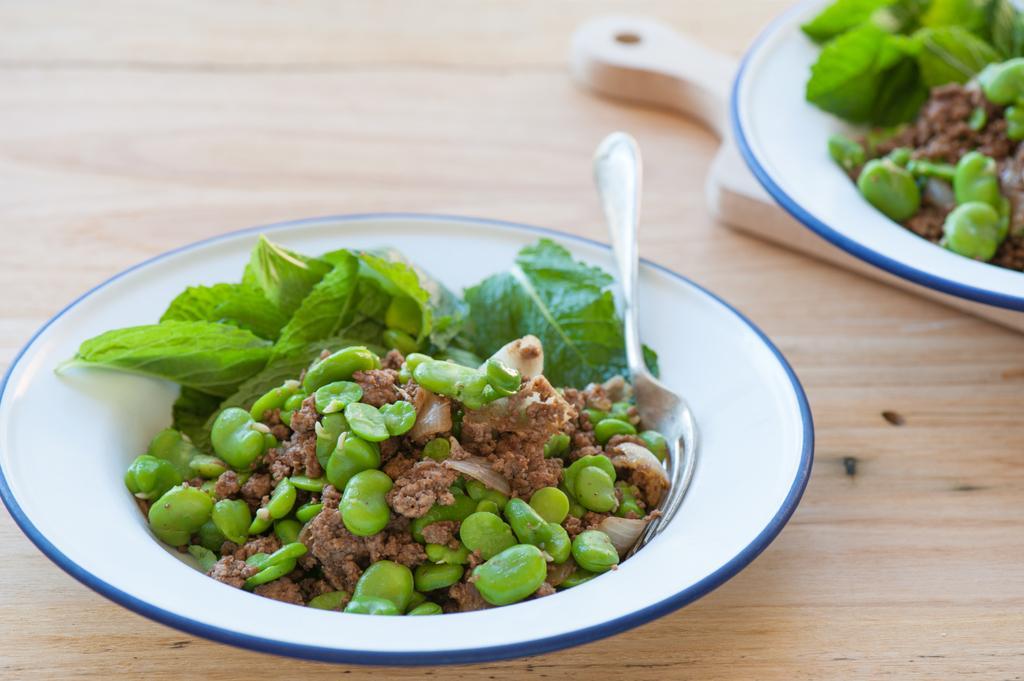In one or two sentences, can you explain what this image depicts? In this image there is a table and we can see plates containing food, tray and a fork placed on the table. 